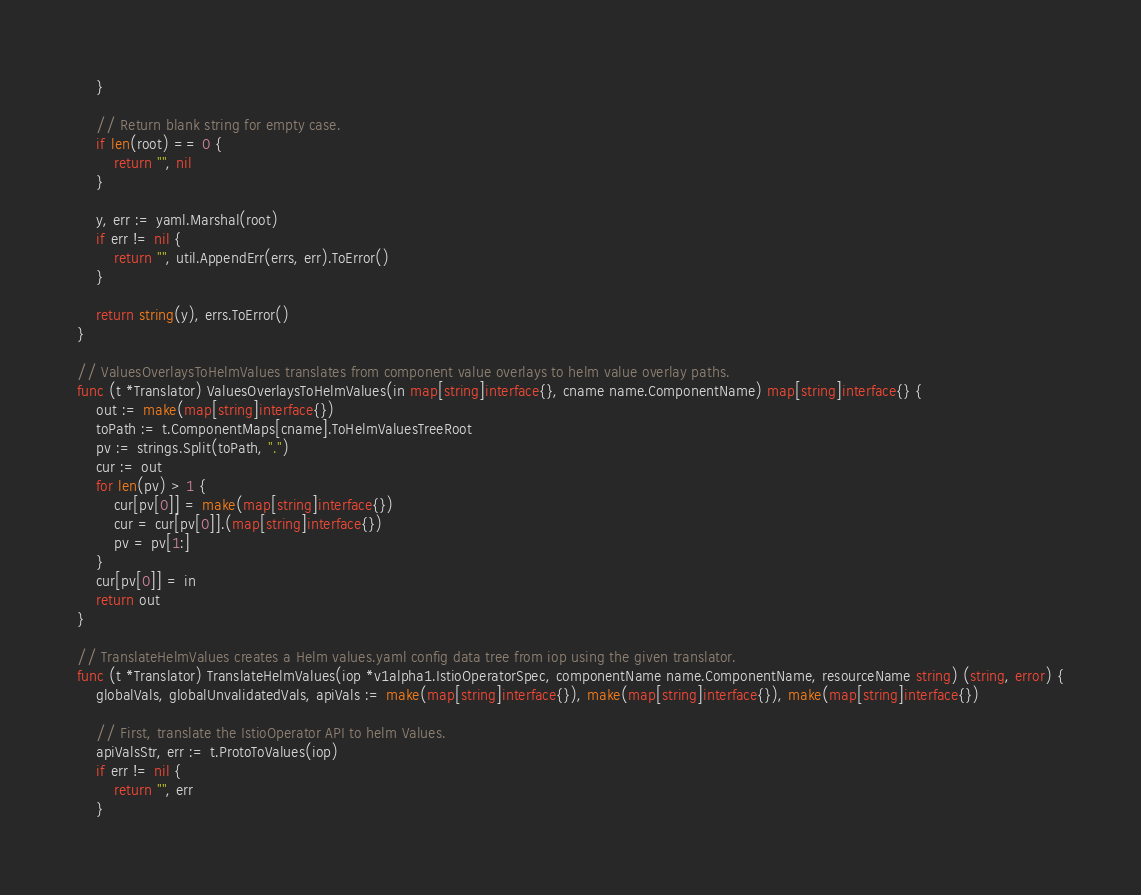Convert code to text. <code><loc_0><loc_0><loc_500><loc_500><_Go_>	}

	// Return blank string for empty case.
	if len(root) == 0 {
		return "", nil
	}

	y, err := yaml.Marshal(root)
	if err != nil {
		return "", util.AppendErr(errs, err).ToError()
	}

	return string(y), errs.ToError()
}

// ValuesOverlaysToHelmValues translates from component value overlays to helm value overlay paths.
func (t *Translator) ValuesOverlaysToHelmValues(in map[string]interface{}, cname name.ComponentName) map[string]interface{} {
	out := make(map[string]interface{})
	toPath := t.ComponentMaps[cname].ToHelmValuesTreeRoot
	pv := strings.Split(toPath, ".")
	cur := out
	for len(pv) > 1 {
		cur[pv[0]] = make(map[string]interface{})
		cur = cur[pv[0]].(map[string]interface{})
		pv = pv[1:]
	}
	cur[pv[0]] = in
	return out
}

// TranslateHelmValues creates a Helm values.yaml config data tree from iop using the given translator.
func (t *Translator) TranslateHelmValues(iop *v1alpha1.IstioOperatorSpec, componentName name.ComponentName, resourceName string) (string, error) {
	globalVals, globalUnvalidatedVals, apiVals := make(map[string]interface{}), make(map[string]interface{}), make(map[string]interface{})

	// First, translate the IstioOperator API to helm Values.
	apiValsStr, err := t.ProtoToValues(iop)
	if err != nil {
		return "", err
	}</code> 